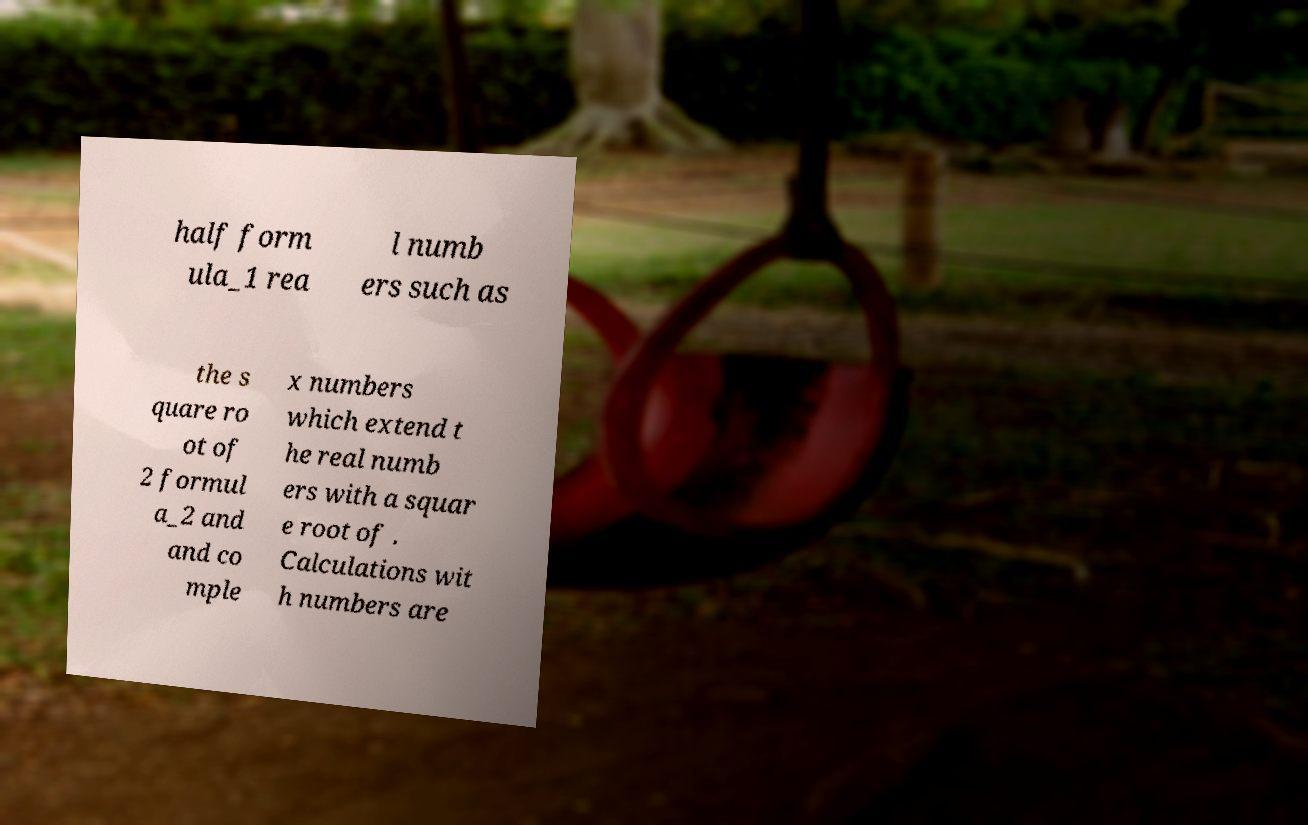What messages or text are displayed in this image? I need them in a readable, typed format. half form ula_1 rea l numb ers such as the s quare ro ot of 2 formul a_2 and and co mple x numbers which extend t he real numb ers with a squar e root of . Calculations wit h numbers are 